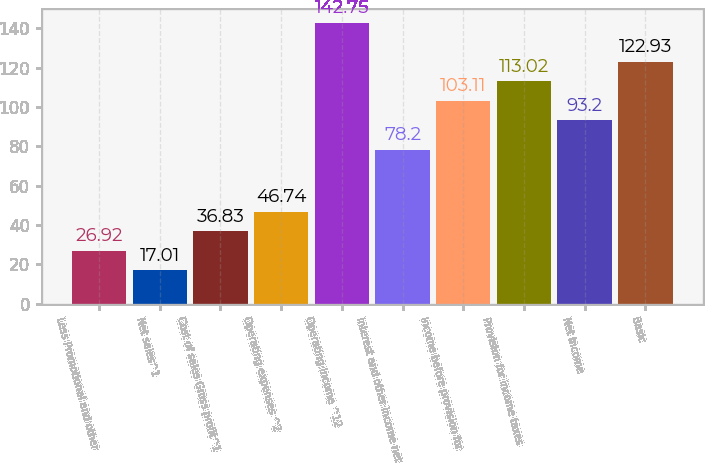<chart> <loc_0><loc_0><loc_500><loc_500><bar_chart><fcel>Less Promotional and other<fcel>Net sales^1<fcel>Cost of sales Gross profit^1<fcel>Operating expenses ^2<fcel>Operating income ^12<fcel>Interest and other income net<fcel>Income before provision for<fcel>Provision for income taxes<fcel>Net income<fcel>Basic<nl><fcel>26.92<fcel>17.01<fcel>36.83<fcel>46.74<fcel>142.75<fcel>78.2<fcel>103.11<fcel>113.02<fcel>93.2<fcel>122.93<nl></chart> 